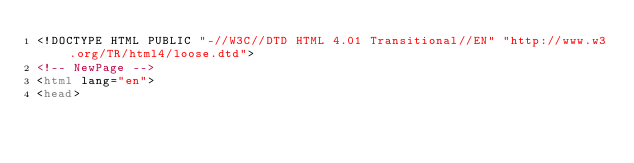Convert code to text. <code><loc_0><loc_0><loc_500><loc_500><_HTML_><!DOCTYPE HTML PUBLIC "-//W3C//DTD HTML 4.01 Transitional//EN" "http://www.w3.org/TR/html4/loose.dtd">
<!-- NewPage -->
<html lang="en">
<head></code> 